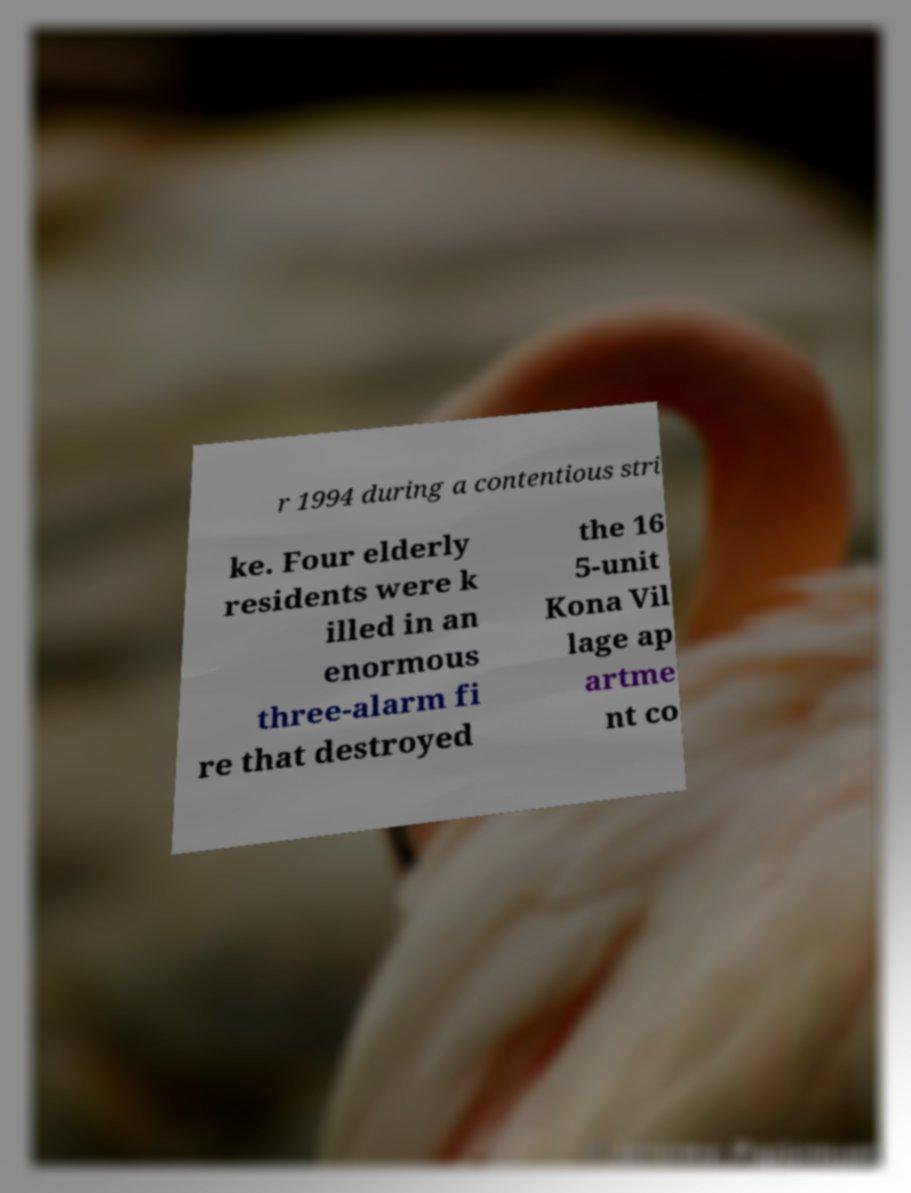What messages or text are displayed in this image? I need them in a readable, typed format. r 1994 during a contentious stri ke. Four elderly residents were k illed in an enormous three-alarm fi re that destroyed the 16 5-unit Kona Vil lage ap artme nt co 